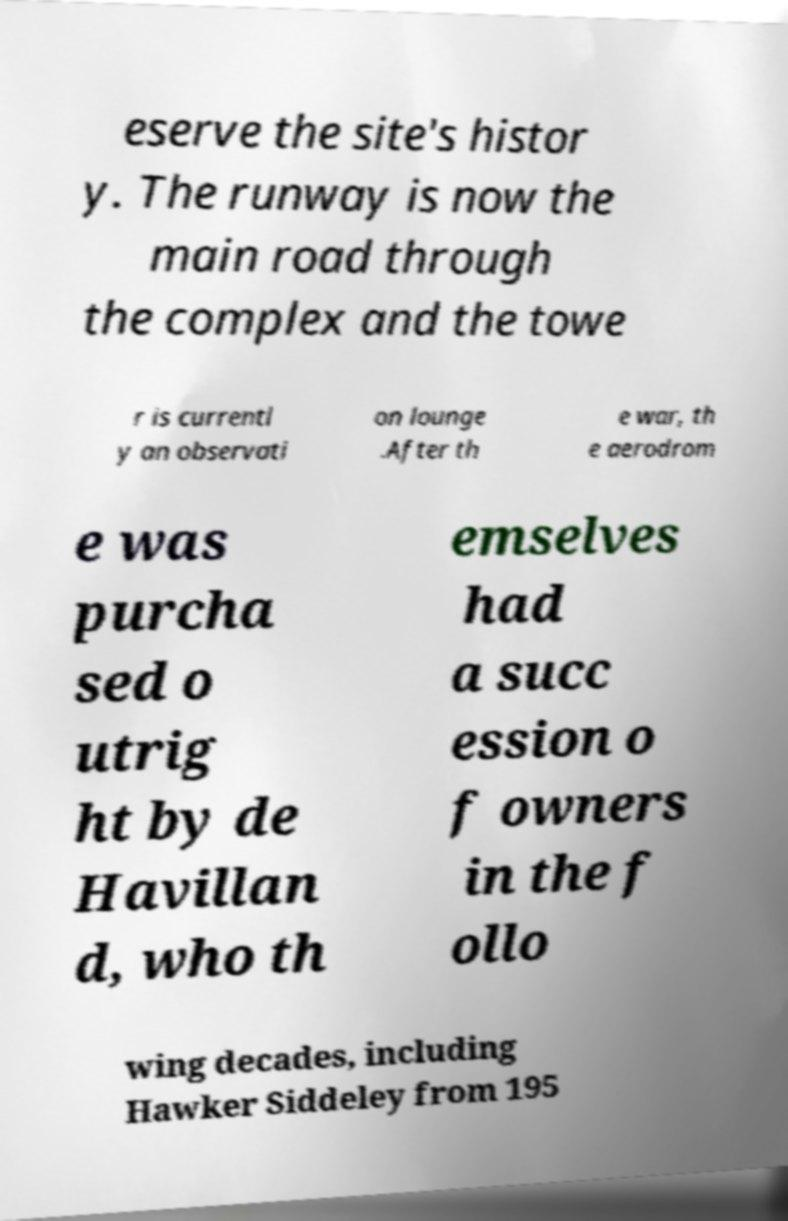Can you read and provide the text displayed in the image?This photo seems to have some interesting text. Can you extract and type it out for me? eserve the site's histor y. The runway is now the main road through the complex and the towe r is currentl y an observati on lounge .After th e war, th e aerodrom e was purcha sed o utrig ht by de Havillan d, who th emselves had a succ ession o f owners in the f ollo wing decades, including Hawker Siddeley from 195 